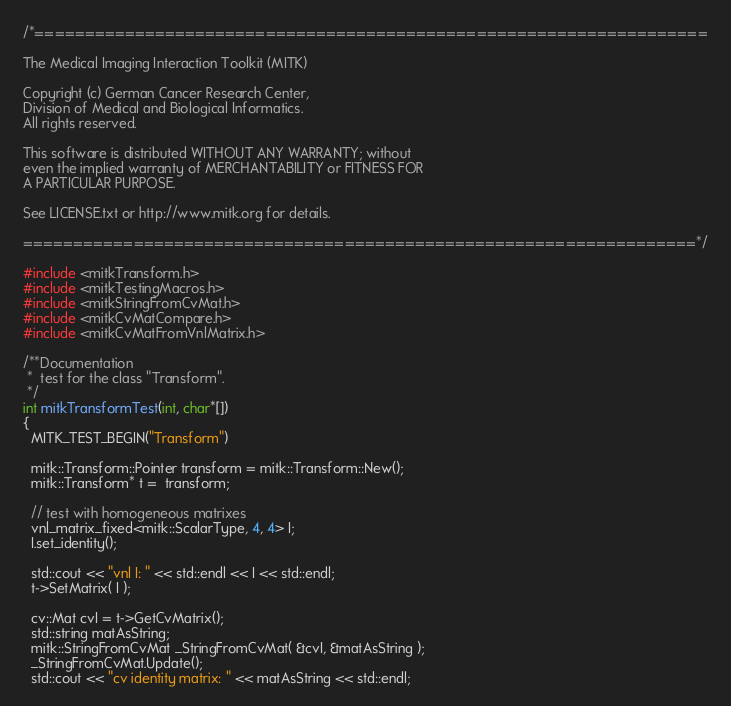<code> <loc_0><loc_0><loc_500><loc_500><_C++_>/*===================================================================

The Medical Imaging Interaction Toolkit (MITK)

Copyright (c) German Cancer Research Center,
Division of Medical and Biological Informatics.
All rights reserved.

This software is distributed WITHOUT ANY WARRANTY; without
even the implied warranty of MERCHANTABILITY or FITNESS FOR
A PARTICULAR PURPOSE.

See LICENSE.txt or http://www.mitk.org for details.

===================================================================*/

#include <mitkTransform.h>
#include <mitkTestingMacros.h>
#include <mitkStringFromCvMat.h>
#include <mitkCvMatCompare.h>
#include <mitkCvMatFromVnlMatrix.h>

/**Documentation
 *  test for the class "Transform".
 */
int mitkTransformTest(int, char*[])
{
  MITK_TEST_BEGIN("Transform")

  mitk::Transform::Pointer transform = mitk::Transform::New();
  mitk::Transform* t =  transform;

  // test with homogeneous matrixes
  vnl_matrix_fixed<mitk::ScalarType, 4, 4> I;
  I.set_identity();

  std::cout << "vnl I: " << std::endl << I << std::endl;
  t->SetMatrix( I );

  cv::Mat cvI = t->GetCvMatrix();
  std::string matAsString;
  mitk::StringFromCvMat _StringFromCvMat( &cvI, &matAsString );
  _StringFromCvMat.Update();
  std::cout << "cv identity matrix: " << matAsString << std::endl;
</code> 